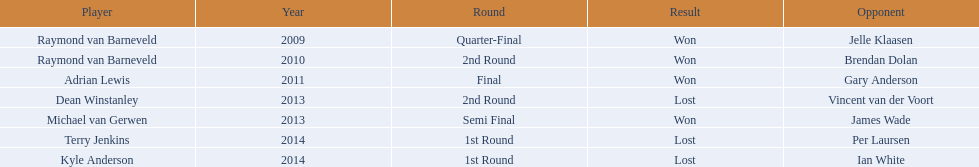Did terry jenkins secure a victory in 2014? Terry Jenkins, Lost. If terry jenkins was defeated, who emerged victorious? Per Laursen. 